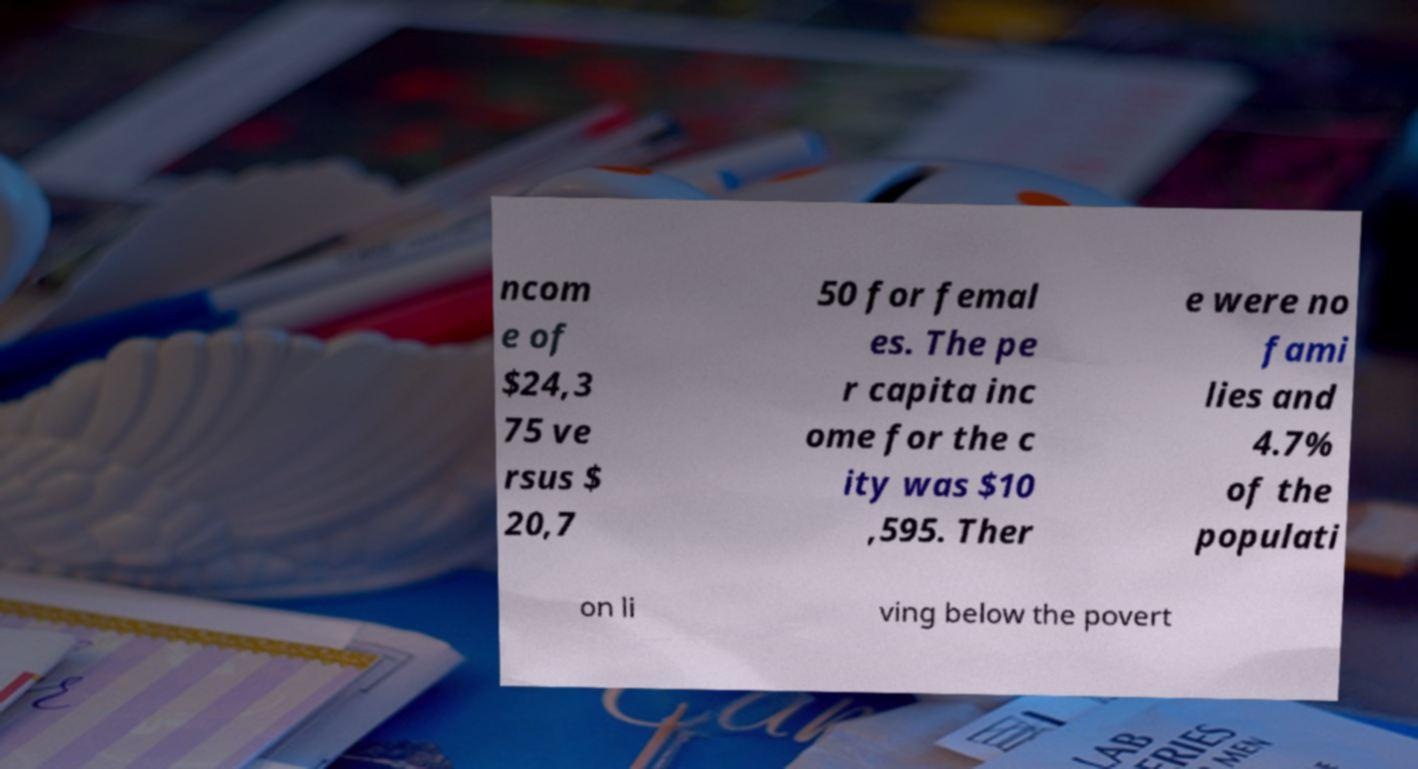Can you read and provide the text displayed in the image?This photo seems to have some interesting text. Can you extract and type it out for me? ncom e of $24,3 75 ve rsus $ 20,7 50 for femal es. The pe r capita inc ome for the c ity was $10 ,595. Ther e were no fami lies and 4.7% of the populati on li ving below the povert 